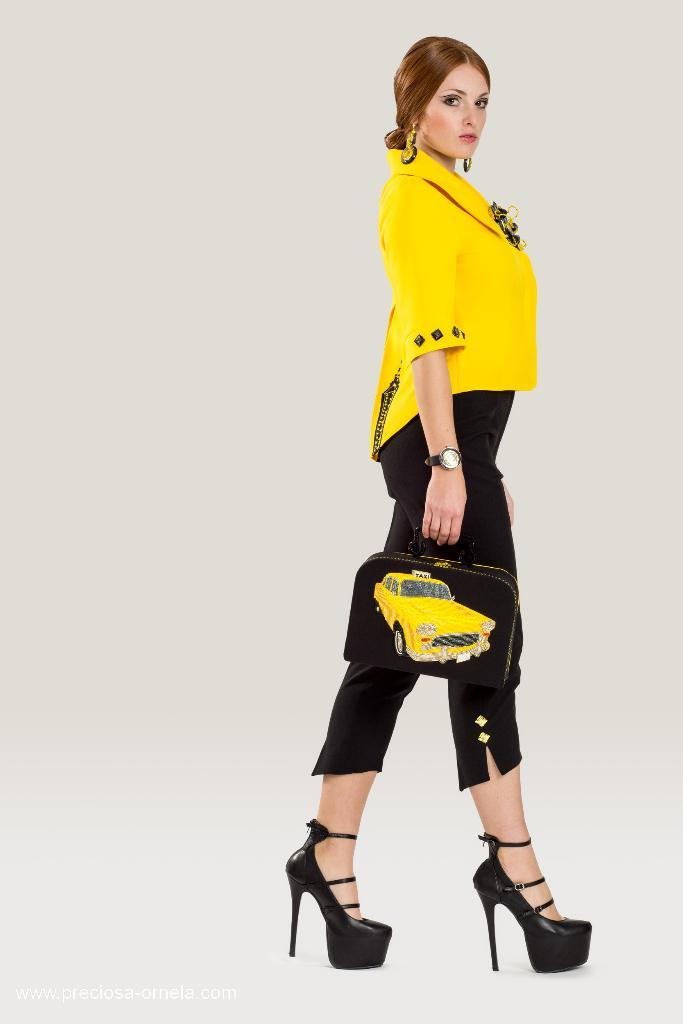What can be seen in the image? There is a person in the image. What is the person holding? The person is holding a black bag. What is the person wearing? The person is wearing a yellow and black color dress. What is the color of the background in the image? The background of the image is white. What type of zinc is present in the image? There is no zinc present in the image. How many legs does the person have in the image? The person has two legs, but this question is unnecessary as the number of legs is not relevant to the image's content. 